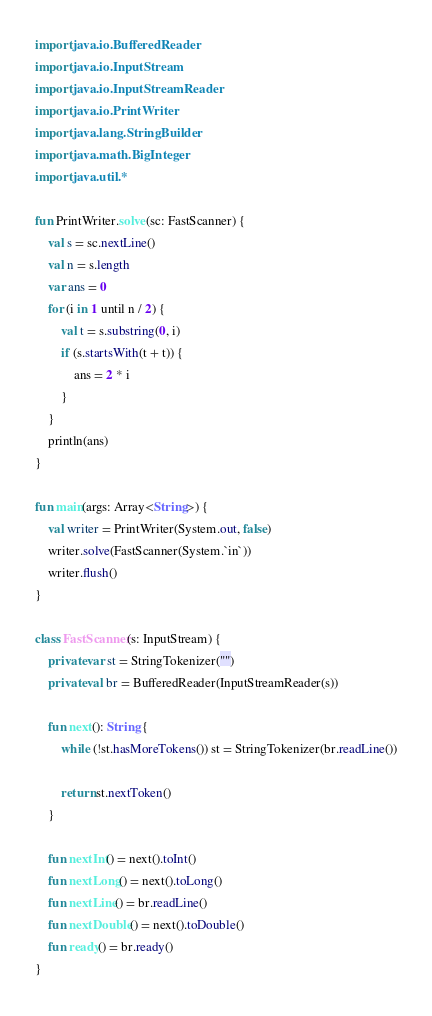<code> <loc_0><loc_0><loc_500><loc_500><_Kotlin_>import java.io.BufferedReader
import java.io.InputStream
import java.io.InputStreamReader
import java.io.PrintWriter
import java.lang.StringBuilder
import java.math.BigInteger
import java.util.*

fun PrintWriter.solve(sc: FastScanner) {
    val s = sc.nextLine()
    val n = s.length
    var ans = 0
    for (i in 1 until n / 2) {
        val t = s.substring(0, i)
        if (s.startsWith(t + t)) {
            ans = 2 * i
        }
    }
    println(ans)
}

fun main(args: Array<String>) {
    val writer = PrintWriter(System.out, false)
    writer.solve(FastScanner(System.`in`))
    writer.flush()
}

class FastScanner(s: InputStream) {
    private var st = StringTokenizer("")
    private val br = BufferedReader(InputStreamReader(s))

    fun next(): String {
        while (!st.hasMoreTokens()) st = StringTokenizer(br.readLine())

        return st.nextToken()
    }

    fun nextInt() = next().toInt()
    fun nextLong() = next().toLong()
    fun nextLine() = br.readLine()
    fun nextDouble() = next().toDouble()
    fun ready() = br.ready()
}
</code> 